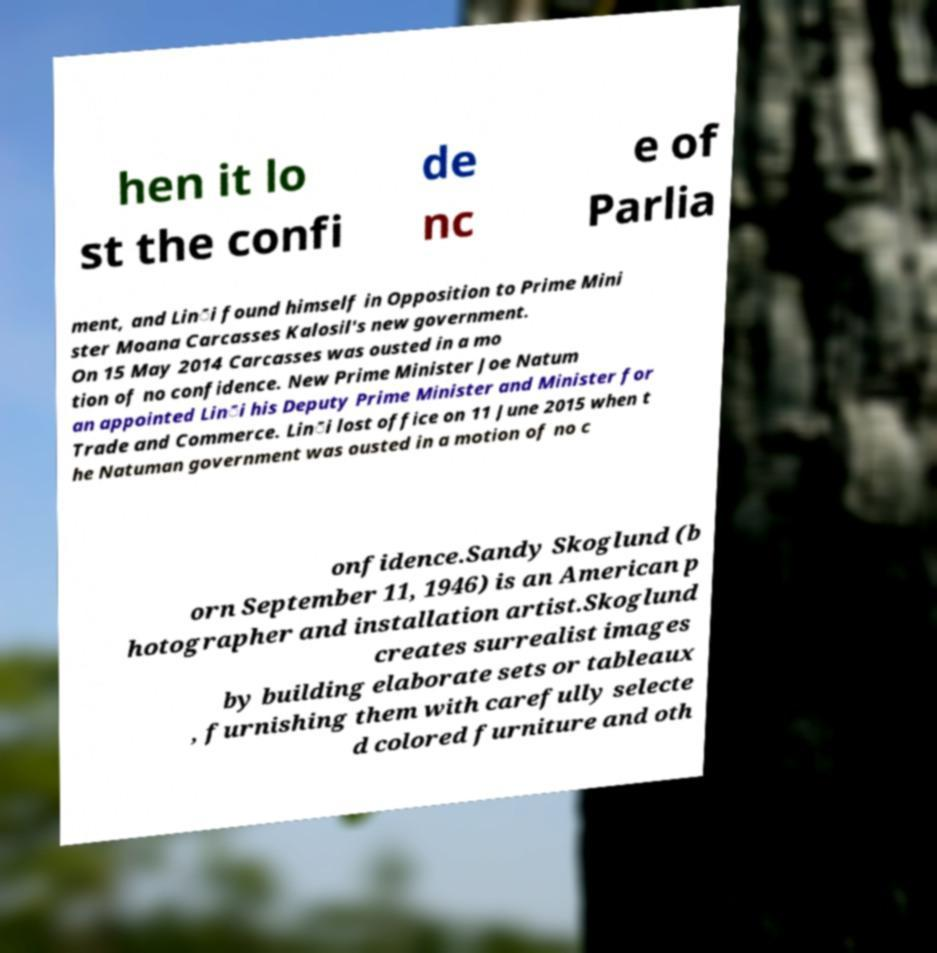There's text embedded in this image that I need extracted. Can you transcribe it verbatim? hen it lo st the confi de nc e of Parlia ment, and Lin̄i found himself in Opposition to Prime Mini ster Moana Carcasses Kalosil's new government. On 15 May 2014 Carcasses was ousted in a mo tion of no confidence. New Prime Minister Joe Natum an appointed Lin̄i his Deputy Prime Minister and Minister for Trade and Commerce. Lin̄i lost office on 11 June 2015 when t he Natuman government was ousted in a motion of no c onfidence.Sandy Skoglund (b orn September 11, 1946) is an American p hotographer and installation artist.Skoglund creates surrealist images by building elaborate sets or tableaux , furnishing them with carefully selecte d colored furniture and oth 